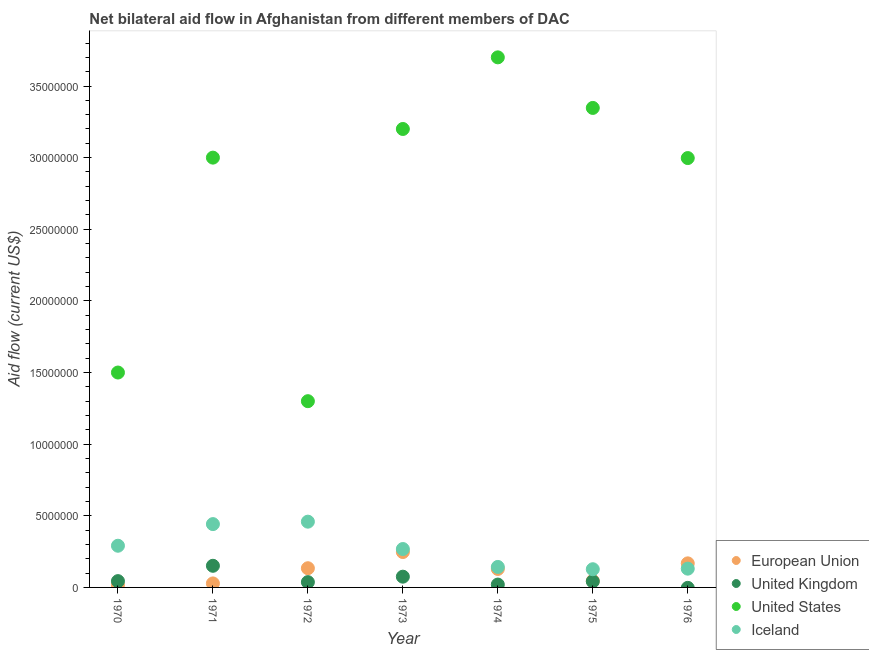What is the amount of aid given by iceland in 1971?
Offer a very short reply. 4.42e+06. Across all years, what is the maximum amount of aid given by iceland?
Give a very brief answer. 4.59e+06. Across all years, what is the minimum amount of aid given by eu?
Make the answer very short. 1.60e+05. In which year was the amount of aid given by iceland maximum?
Keep it short and to the point. 1972. What is the total amount of aid given by eu in the graph?
Offer a very short reply. 7.68e+06. What is the difference between the amount of aid given by iceland in 1970 and that in 1973?
Your answer should be very brief. 2.30e+05. What is the difference between the amount of aid given by eu in 1975 and the amount of aid given by us in 1970?
Your answer should be compact. -1.45e+07. What is the average amount of aid given by eu per year?
Offer a terse response. 1.10e+06. In the year 1974, what is the difference between the amount of aid given by iceland and amount of aid given by us?
Make the answer very short. -3.56e+07. What is the ratio of the amount of aid given by iceland in 1970 to that in 1974?
Ensure brevity in your answer.  2.03. Is the difference between the amount of aid given by us in 1974 and 1976 greater than the difference between the amount of aid given by iceland in 1974 and 1976?
Keep it short and to the point. Yes. What is the difference between the highest and the second highest amount of aid given by us?
Keep it short and to the point. 3.53e+06. What is the difference between the highest and the lowest amount of aid given by uk?
Provide a succinct answer. 1.51e+06. In how many years, is the amount of aid given by us greater than the average amount of aid given by us taken over all years?
Your answer should be very brief. 5. Is it the case that in every year, the sum of the amount of aid given by eu and amount of aid given by iceland is greater than the sum of amount of aid given by us and amount of aid given by uk?
Your response must be concise. No. Does the amount of aid given by iceland monotonically increase over the years?
Your answer should be very brief. No. Is the amount of aid given by iceland strictly greater than the amount of aid given by us over the years?
Your answer should be very brief. No. Is the amount of aid given by us strictly less than the amount of aid given by uk over the years?
Your answer should be very brief. No. Are the values on the major ticks of Y-axis written in scientific E-notation?
Offer a terse response. No. How many legend labels are there?
Offer a terse response. 4. What is the title of the graph?
Ensure brevity in your answer.  Net bilateral aid flow in Afghanistan from different members of DAC. Does "Second 20% of population" appear as one of the legend labels in the graph?
Your response must be concise. No. What is the Aid flow (current US$) of European Union in 1970?
Ensure brevity in your answer.  1.60e+05. What is the Aid flow (current US$) in United States in 1970?
Your answer should be very brief. 1.50e+07. What is the Aid flow (current US$) in Iceland in 1970?
Your answer should be very brief. 2.91e+06. What is the Aid flow (current US$) in European Union in 1971?
Your answer should be compact. 2.80e+05. What is the Aid flow (current US$) in United Kingdom in 1971?
Offer a terse response. 1.51e+06. What is the Aid flow (current US$) in United States in 1971?
Your answer should be compact. 3.00e+07. What is the Aid flow (current US$) of Iceland in 1971?
Provide a short and direct response. 4.42e+06. What is the Aid flow (current US$) in European Union in 1972?
Offer a terse response. 1.34e+06. What is the Aid flow (current US$) in United States in 1972?
Ensure brevity in your answer.  1.30e+07. What is the Aid flow (current US$) of Iceland in 1972?
Ensure brevity in your answer.  4.59e+06. What is the Aid flow (current US$) in European Union in 1973?
Give a very brief answer. 2.47e+06. What is the Aid flow (current US$) of United Kingdom in 1973?
Offer a very short reply. 7.50e+05. What is the Aid flow (current US$) of United States in 1973?
Your answer should be very brief. 3.20e+07. What is the Aid flow (current US$) in Iceland in 1973?
Your answer should be very brief. 2.68e+06. What is the Aid flow (current US$) of European Union in 1974?
Provide a succinct answer. 1.29e+06. What is the Aid flow (current US$) of United States in 1974?
Your response must be concise. 3.70e+07. What is the Aid flow (current US$) of Iceland in 1974?
Provide a succinct answer. 1.43e+06. What is the Aid flow (current US$) of United Kingdom in 1975?
Ensure brevity in your answer.  4.20e+05. What is the Aid flow (current US$) of United States in 1975?
Provide a short and direct response. 3.35e+07. What is the Aid flow (current US$) of Iceland in 1975?
Provide a succinct answer. 1.27e+06. What is the Aid flow (current US$) in European Union in 1976?
Make the answer very short. 1.68e+06. What is the Aid flow (current US$) of United Kingdom in 1976?
Provide a short and direct response. 0. What is the Aid flow (current US$) in United States in 1976?
Your answer should be very brief. 3.00e+07. What is the Aid flow (current US$) in Iceland in 1976?
Offer a very short reply. 1.31e+06. Across all years, what is the maximum Aid flow (current US$) in European Union?
Your answer should be very brief. 2.47e+06. Across all years, what is the maximum Aid flow (current US$) of United Kingdom?
Give a very brief answer. 1.51e+06. Across all years, what is the maximum Aid flow (current US$) of United States?
Give a very brief answer. 3.70e+07. Across all years, what is the maximum Aid flow (current US$) of Iceland?
Give a very brief answer. 4.59e+06. Across all years, what is the minimum Aid flow (current US$) in United Kingdom?
Offer a very short reply. 0. Across all years, what is the minimum Aid flow (current US$) of United States?
Keep it short and to the point. 1.30e+07. Across all years, what is the minimum Aid flow (current US$) of Iceland?
Give a very brief answer. 1.27e+06. What is the total Aid flow (current US$) of European Union in the graph?
Ensure brevity in your answer.  7.68e+06. What is the total Aid flow (current US$) in United Kingdom in the graph?
Make the answer very short. 3.69e+06. What is the total Aid flow (current US$) of United States in the graph?
Give a very brief answer. 1.90e+08. What is the total Aid flow (current US$) in Iceland in the graph?
Ensure brevity in your answer.  1.86e+07. What is the difference between the Aid flow (current US$) of United Kingdom in 1970 and that in 1971?
Provide a short and direct response. -1.07e+06. What is the difference between the Aid flow (current US$) in United States in 1970 and that in 1971?
Provide a succinct answer. -1.50e+07. What is the difference between the Aid flow (current US$) in Iceland in 1970 and that in 1971?
Keep it short and to the point. -1.51e+06. What is the difference between the Aid flow (current US$) in European Union in 1970 and that in 1972?
Your answer should be very brief. -1.18e+06. What is the difference between the Aid flow (current US$) of Iceland in 1970 and that in 1972?
Provide a short and direct response. -1.68e+06. What is the difference between the Aid flow (current US$) in European Union in 1970 and that in 1973?
Your answer should be compact. -2.31e+06. What is the difference between the Aid flow (current US$) of United Kingdom in 1970 and that in 1973?
Keep it short and to the point. -3.10e+05. What is the difference between the Aid flow (current US$) of United States in 1970 and that in 1973?
Keep it short and to the point. -1.70e+07. What is the difference between the Aid flow (current US$) in European Union in 1970 and that in 1974?
Give a very brief answer. -1.13e+06. What is the difference between the Aid flow (current US$) in United States in 1970 and that in 1974?
Give a very brief answer. -2.20e+07. What is the difference between the Aid flow (current US$) in Iceland in 1970 and that in 1974?
Your answer should be compact. 1.48e+06. What is the difference between the Aid flow (current US$) of European Union in 1970 and that in 1975?
Make the answer very short. -3.00e+05. What is the difference between the Aid flow (current US$) in United States in 1970 and that in 1975?
Provide a succinct answer. -1.85e+07. What is the difference between the Aid flow (current US$) in Iceland in 1970 and that in 1975?
Make the answer very short. 1.64e+06. What is the difference between the Aid flow (current US$) of European Union in 1970 and that in 1976?
Provide a short and direct response. -1.52e+06. What is the difference between the Aid flow (current US$) of United States in 1970 and that in 1976?
Keep it short and to the point. -1.50e+07. What is the difference between the Aid flow (current US$) in Iceland in 1970 and that in 1976?
Your answer should be very brief. 1.60e+06. What is the difference between the Aid flow (current US$) in European Union in 1971 and that in 1972?
Make the answer very short. -1.06e+06. What is the difference between the Aid flow (current US$) of United Kingdom in 1971 and that in 1972?
Your answer should be compact. 1.14e+06. What is the difference between the Aid flow (current US$) of United States in 1971 and that in 1972?
Make the answer very short. 1.70e+07. What is the difference between the Aid flow (current US$) of European Union in 1971 and that in 1973?
Provide a succinct answer. -2.19e+06. What is the difference between the Aid flow (current US$) of United Kingdom in 1971 and that in 1973?
Make the answer very short. 7.60e+05. What is the difference between the Aid flow (current US$) of United States in 1971 and that in 1973?
Provide a short and direct response. -2.00e+06. What is the difference between the Aid flow (current US$) in Iceland in 1971 and that in 1973?
Your answer should be compact. 1.74e+06. What is the difference between the Aid flow (current US$) of European Union in 1971 and that in 1974?
Provide a short and direct response. -1.01e+06. What is the difference between the Aid flow (current US$) of United Kingdom in 1971 and that in 1974?
Offer a very short reply. 1.31e+06. What is the difference between the Aid flow (current US$) of United States in 1971 and that in 1974?
Your answer should be compact. -7.00e+06. What is the difference between the Aid flow (current US$) in Iceland in 1971 and that in 1974?
Ensure brevity in your answer.  2.99e+06. What is the difference between the Aid flow (current US$) in United Kingdom in 1971 and that in 1975?
Provide a short and direct response. 1.09e+06. What is the difference between the Aid flow (current US$) of United States in 1971 and that in 1975?
Offer a terse response. -3.47e+06. What is the difference between the Aid flow (current US$) of Iceland in 1971 and that in 1975?
Offer a terse response. 3.15e+06. What is the difference between the Aid flow (current US$) in European Union in 1971 and that in 1976?
Provide a succinct answer. -1.40e+06. What is the difference between the Aid flow (current US$) of Iceland in 1971 and that in 1976?
Ensure brevity in your answer.  3.11e+06. What is the difference between the Aid flow (current US$) of European Union in 1972 and that in 1973?
Offer a very short reply. -1.13e+06. What is the difference between the Aid flow (current US$) in United Kingdom in 1972 and that in 1973?
Your response must be concise. -3.80e+05. What is the difference between the Aid flow (current US$) of United States in 1972 and that in 1973?
Offer a terse response. -1.90e+07. What is the difference between the Aid flow (current US$) of Iceland in 1972 and that in 1973?
Your answer should be compact. 1.91e+06. What is the difference between the Aid flow (current US$) in European Union in 1972 and that in 1974?
Your answer should be very brief. 5.00e+04. What is the difference between the Aid flow (current US$) of United States in 1972 and that in 1974?
Provide a succinct answer. -2.40e+07. What is the difference between the Aid flow (current US$) in Iceland in 1972 and that in 1974?
Make the answer very short. 3.16e+06. What is the difference between the Aid flow (current US$) of European Union in 1972 and that in 1975?
Keep it short and to the point. 8.80e+05. What is the difference between the Aid flow (current US$) of United Kingdom in 1972 and that in 1975?
Make the answer very short. -5.00e+04. What is the difference between the Aid flow (current US$) of United States in 1972 and that in 1975?
Your answer should be compact. -2.05e+07. What is the difference between the Aid flow (current US$) of Iceland in 1972 and that in 1975?
Make the answer very short. 3.32e+06. What is the difference between the Aid flow (current US$) of United States in 1972 and that in 1976?
Ensure brevity in your answer.  -1.70e+07. What is the difference between the Aid flow (current US$) in Iceland in 1972 and that in 1976?
Make the answer very short. 3.28e+06. What is the difference between the Aid flow (current US$) of European Union in 1973 and that in 1974?
Give a very brief answer. 1.18e+06. What is the difference between the Aid flow (current US$) of United States in 1973 and that in 1974?
Provide a succinct answer. -5.00e+06. What is the difference between the Aid flow (current US$) of Iceland in 1973 and that in 1974?
Make the answer very short. 1.25e+06. What is the difference between the Aid flow (current US$) in European Union in 1973 and that in 1975?
Your answer should be very brief. 2.01e+06. What is the difference between the Aid flow (current US$) of United Kingdom in 1973 and that in 1975?
Offer a terse response. 3.30e+05. What is the difference between the Aid flow (current US$) of United States in 1973 and that in 1975?
Your answer should be compact. -1.47e+06. What is the difference between the Aid flow (current US$) of Iceland in 1973 and that in 1975?
Offer a very short reply. 1.41e+06. What is the difference between the Aid flow (current US$) in European Union in 1973 and that in 1976?
Offer a terse response. 7.90e+05. What is the difference between the Aid flow (current US$) of United States in 1973 and that in 1976?
Provide a succinct answer. 2.03e+06. What is the difference between the Aid flow (current US$) in Iceland in 1973 and that in 1976?
Provide a short and direct response. 1.37e+06. What is the difference between the Aid flow (current US$) of European Union in 1974 and that in 1975?
Ensure brevity in your answer.  8.30e+05. What is the difference between the Aid flow (current US$) in United Kingdom in 1974 and that in 1975?
Provide a short and direct response. -2.20e+05. What is the difference between the Aid flow (current US$) of United States in 1974 and that in 1975?
Provide a short and direct response. 3.53e+06. What is the difference between the Aid flow (current US$) in Iceland in 1974 and that in 1975?
Offer a terse response. 1.60e+05. What is the difference between the Aid flow (current US$) of European Union in 1974 and that in 1976?
Offer a terse response. -3.90e+05. What is the difference between the Aid flow (current US$) of United States in 1974 and that in 1976?
Provide a short and direct response. 7.03e+06. What is the difference between the Aid flow (current US$) of European Union in 1975 and that in 1976?
Keep it short and to the point. -1.22e+06. What is the difference between the Aid flow (current US$) in United States in 1975 and that in 1976?
Ensure brevity in your answer.  3.50e+06. What is the difference between the Aid flow (current US$) in European Union in 1970 and the Aid flow (current US$) in United Kingdom in 1971?
Your answer should be compact. -1.35e+06. What is the difference between the Aid flow (current US$) in European Union in 1970 and the Aid flow (current US$) in United States in 1971?
Your answer should be compact. -2.98e+07. What is the difference between the Aid flow (current US$) of European Union in 1970 and the Aid flow (current US$) of Iceland in 1971?
Ensure brevity in your answer.  -4.26e+06. What is the difference between the Aid flow (current US$) of United Kingdom in 1970 and the Aid flow (current US$) of United States in 1971?
Give a very brief answer. -2.96e+07. What is the difference between the Aid flow (current US$) of United Kingdom in 1970 and the Aid flow (current US$) of Iceland in 1971?
Your answer should be compact. -3.98e+06. What is the difference between the Aid flow (current US$) of United States in 1970 and the Aid flow (current US$) of Iceland in 1971?
Your response must be concise. 1.06e+07. What is the difference between the Aid flow (current US$) in European Union in 1970 and the Aid flow (current US$) in United States in 1972?
Your answer should be compact. -1.28e+07. What is the difference between the Aid flow (current US$) of European Union in 1970 and the Aid flow (current US$) of Iceland in 1972?
Keep it short and to the point. -4.43e+06. What is the difference between the Aid flow (current US$) in United Kingdom in 1970 and the Aid flow (current US$) in United States in 1972?
Give a very brief answer. -1.26e+07. What is the difference between the Aid flow (current US$) of United Kingdom in 1970 and the Aid flow (current US$) of Iceland in 1972?
Keep it short and to the point. -4.15e+06. What is the difference between the Aid flow (current US$) of United States in 1970 and the Aid flow (current US$) of Iceland in 1972?
Make the answer very short. 1.04e+07. What is the difference between the Aid flow (current US$) of European Union in 1970 and the Aid flow (current US$) of United Kingdom in 1973?
Ensure brevity in your answer.  -5.90e+05. What is the difference between the Aid flow (current US$) of European Union in 1970 and the Aid flow (current US$) of United States in 1973?
Ensure brevity in your answer.  -3.18e+07. What is the difference between the Aid flow (current US$) in European Union in 1970 and the Aid flow (current US$) in Iceland in 1973?
Give a very brief answer. -2.52e+06. What is the difference between the Aid flow (current US$) in United Kingdom in 1970 and the Aid flow (current US$) in United States in 1973?
Your answer should be compact. -3.16e+07. What is the difference between the Aid flow (current US$) in United Kingdom in 1970 and the Aid flow (current US$) in Iceland in 1973?
Keep it short and to the point. -2.24e+06. What is the difference between the Aid flow (current US$) of United States in 1970 and the Aid flow (current US$) of Iceland in 1973?
Keep it short and to the point. 1.23e+07. What is the difference between the Aid flow (current US$) in European Union in 1970 and the Aid flow (current US$) in United Kingdom in 1974?
Your answer should be very brief. -4.00e+04. What is the difference between the Aid flow (current US$) in European Union in 1970 and the Aid flow (current US$) in United States in 1974?
Ensure brevity in your answer.  -3.68e+07. What is the difference between the Aid flow (current US$) in European Union in 1970 and the Aid flow (current US$) in Iceland in 1974?
Give a very brief answer. -1.27e+06. What is the difference between the Aid flow (current US$) of United Kingdom in 1970 and the Aid flow (current US$) of United States in 1974?
Give a very brief answer. -3.66e+07. What is the difference between the Aid flow (current US$) of United Kingdom in 1970 and the Aid flow (current US$) of Iceland in 1974?
Provide a succinct answer. -9.90e+05. What is the difference between the Aid flow (current US$) in United States in 1970 and the Aid flow (current US$) in Iceland in 1974?
Provide a succinct answer. 1.36e+07. What is the difference between the Aid flow (current US$) in European Union in 1970 and the Aid flow (current US$) in United Kingdom in 1975?
Give a very brief answer. -2.60e+05. What is the difference between the Aid flow (current US$) of European Union in 1970 and the Aid flow (current US$) of United States in 1975?
Your answer should be very brief. -3.33e+07. What is the difference between the Aid flow (current US$) of European Union in 1970 and the Aid flow (current US$) of Iceland in 1975?
Your response must be concise. -1.11e+06. What is the difference between the Aid flow (current US$) of United Kingdom in 1970 and the Aid flow (current US$) of United States in 1975?
Your answer should be very brief. -3.30e+07. What is the difference between the Aid flow (current US$) of United Kingdom in 1970 and the Aid flow (current US$) of Iceland in 1975?
Ensure brevity in your answer.  -8.30e+05. What is the difference between the Aid flow (current US$) of United States in 1970 and the Aid flow (current US$) of Iceland in 1975?
Ensure brevity in your answer.  1.37e+07. What is the difference between the Aid flow (current US$) in European Union in 1970 and the Aid flow (current US$) in United States in 1976?
Your answer should be very brief. -2.98e+07. What is the difference between the Aid flow (current US$) of European Union in 1970 and the Aid flow (current US$) of Iceland in 1976?
Make the answer very short. -1.15e+06. What is the difference between the Aid flow (current US$) of United Kingdom in 1970 and the Aid flow (current US$) of United States in 1976?
Offer a terse response. -2.95e+07. What is the difference between the Aid flow (current US$) of United Kingdom in 1970 and the Aid flow (current US$) of Iceland in 1976?
Your answer should be very brief. -8.70e+05. What is the difference between the Aid flow (current US$) of United States in 1970 and the Aid flow (current US$) of Iceland in 1976?
Keep it short and to the point. 1.37e+07. What is the difference between the Aid flow (current US$) in European Union in 1971 and the Aid flow (current US$) in United States in 1972?
Your answer should be compact. -1.27e+07. What is the difference between the Aid flow (current US$) of European Union in 1971 and the Aid flow (current US$) of Iceland in 1972?
Give a very brief answer. -4.31e+06. What is the difference between the Aid flow (current US$) in United Kingdom in 1971 and the Aid flow (current US$) in United States in 1972?
Provide a succinct answer. -1.15e+07. What is the difference between the Aid flow (current US$) in United Kingdom in 1971 and the Aid flow (current US$) in Iceland in 1972?
Offer a terse response. -3.08e+06. What is the difference between the Aid flow (current US$) of United States in 1971 and the Aid flow (current US$) of Iceland in 1972?
Keep it short and to the point. 2.54e+07. What is the difference between the Aid flow (current US$) in European Union in 1971 and the Aid flow (current US$) in United Kingdom in 1973?
Your answer should be very brief. -4.70e+05. What is the difference between the Aid flow (current US$) of European Union in 1971 and the Aid flow (current US$) of United States in 1973?
Make the answer very short. -3.17e+07. What is the difference between the Aid flow (current US$) of European Union in 1971 and the Aid flow (current US$) of Iceland in 1973?
Offer a terse response. -2.40e+06. What is the difference between the Aid flow (current US$) of United Kingdom in 1971 and the Aid flow (current US$) of United States in 1973?
Your answer should be very brief. -3.05e+07. What is the difference between the Aid flow (current US$) of United Kingdom in 1971 and the Aid flow (current US$) of Iceland in 1973?
Make the answer very short. -1.17e+06. What is the difference between the Aid flow (current US$) of United States in 1971 and the Aid flow (current US$) of Iceland in 1973?
Ensure brevity in your answer.  2.73e+07. What is the difference between the Aid flow (current US$) in European Union in 1971 and the Aid flow (current US$) in United Kingdom in 1974?
Provide a short and direct response. 8.00e+04. What is the difference between the Aid flow (current US$) of European Union in 1971 and the Aid flow (current US$) of United States in 1974?
Provide a succinct answer. -3.67e+07. What is the difference between the Aid flow (current US$) of European Union in 1971 and the Aid flow (current US$) of Iceland in 1974?
Give a very brief answer. -1.15e+06. What is the difference between the Aid flow (current US$) in United Kingdom in 1971 and the Aid flow (current US$) in United States in 1974?
Your response must be concise. -3.55e+07. What is the difference between the Aid flow (current US$) of United Kingdom in 1971 and the Aid flow (current US$) of Iceland in 1974?
Your answer should be compact. 8.00e+04. What is the difference between the Aid flow (current US$) in United States in 1971 and the Aid flow (current US$) in Iceland in 1974?
Provide a succinct answer. 2.86e+07. What is the difference between the Aid flow (current US$) in European Union in 1971 and the Aid flow (current US$) in United Kingdom in 1975?
Make the answer very short. -1.40e+05. What is the difference between the Aid flow (current US$) in European Union in 1971 and the Aid flow (current US$) in United States in 1975?
Ensure brevity in your answer.  -3.32e+07. What is the difference between the Aid flow (current US$) in European Union in 1971 and the Aid flow (current US$) in Iceland in 1975?
Offer a very short reply. -9.90e+05. What is the difference between the Aid flow (current US$) of United Kingdom in 1971 and the Aid flow (current US$) of United States in 1975?
Make the answer very short. -3.20e+07. What is the difference between the Aid flow (current US$) in United States in 1971 and the Aid flow (current US$) in Iceland in 1975?
Make the answer very short. 2.87e+07. What is the difference between the Aid flow (current US$) of European Union in 1971 and the Aid flow (current US$) of United States in 1976?
Provide a short and direct response. -2.97e+07. What is the difference between the Aid flow (current US$) in European Union in 1971 and the Aid flow (current US$) in Iceland in 1976?
Provide a short and direct response. -1.03e+06. What is the difference between the Aid flow (current US$) of United Kingdom in 1971 and the Aid flow (current US$) of United States in 1976?
Offer a very short reply. -2.85e+07. What is the difference between the Aid flow (current US$) of United Kingdom in 1971 and the Aid flow (current US$) of Iceland in 1976?
Give a very brief answer. 2.00e+05. What is the difference between the Aid flow (current US$) in United States in 1971 and the Aid flow (current US$) in Iceland in 1976?
Your answer should be compact. 2.87e+07. What is the difference between the Aid flow (current US$) of European Union in 1972 and the Aid flow (current US$) of United Kingdom in 1973?
Offer a very short reply. 5.90e+05. What is the difference between the Aid flow (current US$) in European Union in 1972 and the Aid flow (current US$) in United States in 1973?
Your answer should be compact. -3.07e+07. What is the difference between the Aid flow (current US$) in European Union in 1972 and the Aid flow (current US$) in Iceland in 1973?
Your response must be concise. -1.34e+06. What is the difference between the Aid flow (current US$) in United Kingdom in 1972 and the Aid flow (current US$) in United States in 1973?
Ensure brevity in your answer.  -3.16e+07. What is the difference between the Aid flow (current US$) of United Kingdom in 1972 and the Aid flow (current US$) of Iceland in 1973?
Give a very brief answer. -2.31e+06. What is the difference between the Aid flow (current US$) in United States in 1972 and the Aid flow (current US$) in Iceland in 1973?
Your response must be concise. 1.03e+07. What is the difference between the Aid flow (current US$) of European Union in 1972 and the Aid flow (current US$) of United Kingdom in 1974?
Your answer should be very brief. 1.14e+06. What is the difference between the Aid flow (current US$) of European Union in 1972 and the Aid flow (current US$) of United States in 1974?
Keep it short and to the point. -3.57e+07. What is the difference between the Aid flow (current US$) of European Union in 1972 and the Aid flow (current US$) of Iceland in 1974?
Your response must be concise. -9.00e+04. What is the difference between the Aid flow (current US$) in United Kingdom in 1972 and the Aid flow (current US$) in United States in 1974?
Give a very brief answer. -3.66e+07. What is the difference between the Aid flow (current US$) of United Kingdom in 1972 and the Aid flow (current US$) of Iceland in 1974?
Keep it short and to the point. -1.06e+06. What is the difference between the Aid flow (current US$) in United States in 1972 and the Aid flow (current US$) in Iceland in 1974?
Provide a succinct answer. 1.16e+07. What is the difference between the Aid flow (current US$) of European Union in 1972 and the Aid flow (current US$) of United Kingdom in 1975?
Give a very brief answer. 9.20e+05. What is the difference between the Aid flow (current US$) in European Union in 1972 and the Aid flow (current US$) in United States in 1975?
Keep it short and to the point. -3.21e+07. What is the difference between the Aid flow (current US$) in United Kingdom in 1972 and the Aid flow (current US$) in United States in 1975?
Offer a terse response. -3.31e+07. What is the difference between the Aid flow (current US$) in United Kingdom in 1972 and the Aid flow (current US$) in Iceland in 1975?
Offer a very short reply. -9.00e+05. What is the difference between the Aid flow (current US$) of United States in 1972 and the Aid flow (current US$) of Iceland in 1975?
Provide a succinct answer. 1.17e+07. What is the difference between the Aid flow (current US$) of European Union in 1972 and the Aid flow (current US$) of United States in 1976?
Provide a short and direct response. -2.86e+07. What is the difference between the Aid flow (current US$) of United Kingdom in 1972 and the Aid flow (current US$) of United States in 1976?
Your answer should be compact. -2.96e+07. What is the difference between the Aid flow (current US$) in United Kingdom in 1972 and the Aid flow (current US$) in Iceland in 1976?
Give a very brief answer. -9.40e+05. What is the difference between the Aid flow (current US$) in United States in 1972 and the Aid flow (current US$) in Iceland in 1976?
Provide a short and direct response. 1.17e+07. What is the difference between the Aid flow (current US$) in European Union in 1973 and the Aid flow (current US$) in United Kingdom in 1974?
Ensure brevity in your answer.  2.27e+06. What is the difference between the Aid flow (current US$) of European Union in 1973 and the Aid flow (current US$) of United States in 1974?
Keep it short and to the point. -3.45e+07. What is the difference between the Aid flow (current US$) of European Union in 1973 and the Aid flow (current US$) of Iceland in 1974?
Your response must be concise. 1.04e+06. What is the difference between the Aid flow (current US$) of United Kingdom in 1973 and the Aid flow (current US$) of United States in 1974?
Offer a terse response. -3.62e+07. What is the difference between the Aid flow (current US$) of United Kingdom in 1973 and the Aid flow (current US$) of Iceland in 1974?
Provide a succinct answer. -6.80e+05. What is the difference between the Aid flow (current US$) of United States in 1973 and the Aid flow (current US$) of Iceland in 1974?
Your answer should be compact. 3.06e+07. What is the difference between the Aid flow (current US$) in European Union in 1973 and the Aid flow (current US$) in United Kingdom in 1975?
Your answer should be compact. 2.05e+06. What is the difference between the Aid flow (current US$) of European Union in 1973 and the Aid flow (current US$) of United States in 1975?
Keep it short and to the point. -3.10e+07. What is the difference between the Aid flow (current US$) in European Union in 1973 and the Aid flow (current US$) in Iceland in 1975?
Ensure brevity in your answer.  1.20e+06. What is the difference between the Aid flow (current US$) of United Kingdom in 1973 and the Aid flow (current US$) of United States in 1975?
Your response must be concise. -3.27e+07. What is the difference between the Aid flow (current US$) in United Kingdom in 1973 and the Aid flow (current US$) in Iceland in 1975?
Give a very brief answer. -5.20e+05. What is the difference between the Aid flow (current US$) of United States in 1973 and the Aid flow (current US$) of Iceland in 1975?
Make the answer very short. 3.07e+07. What is the difference between the Aid flow (current US$) in European Union in 1973 and the Aid flow (current US$) in United States in 1976?
Your response must be concise. -2.75e+07. What is the difference between the Aid flow (current US$) of European Union in 1973 and the Aid flow (current US$) of Iceland in 1976?
Give a very brief answer. 1.16e+06. What is the difference between the Aid flow (current US$) in United Kingdom in 1973 and the Aid flow (current US$) in United States in 1976?
Provide a short and direct response. -2.92e+07. What is the difference between the Aid flow (current US$) in United Kingdom in 1973 and the Aid flow (current US$) in Iceland in 1976?
Your answer should be compact. -5.60e+05. What is the difference between the Aid flow (current US$) in United States in 1973 and the Aid flow (current US$) in Iceland in 1976?
Give a very brief answer. 3.07e+07. What is the difference between the Aid flow (current US$) in European Union in 1974 and the Aid flow (current US$) in United Kingdom in 1975?
Give a very brief answer. 8.70e+05. What is the difference between the Aid flow (current US$) in European Union in 1974 and the Aid flow (current US$) in United States in 1975?
Your answer should be compact. -3.22e+07. What is the difference between the Aid flow (current US$) of European Union in 1974 and the Aid flow (current US$) of Iceland in 1975?
Provide a succinct answer. 2.00e+04. What is the difference between the Aid flow (current US$) in United Kingdom in 1974 and the Aid flow (current US$) in United States in 1975?
Your answer should be compact. -3.33e+07. What is the difference between the Aid flow (current US$) in United Kingdom in 1974 and the Aid flow (current US$) in Iceland in 1975?
Offer a very short reply. -1.07e+06. What is the difference between the Aid flow (current US$) in United States in 1974 and the Aid flow (current US$) in Iceland in 1975?
Make the answer very short. 3.57e+07. What is the difference between the Aid flow (current US$) in European Union in 1974 and the Aid flow (current US$) in United States in 1976?
Offer a very short reply. -2.87e+07. What is the difference between the Aid flow (current US$) of United Kingdom in 1974 and the Aid flow (current US$) of United States in 1976?
Make the answer very short. -2.98e+07. What is the difference between the Aid flow (current US$) of United Kingdom in 1974 and the Aid flow (current US$) of Iceland in 1976?
Make the answer very short. -1.11e+06. What is the difference between the Aid flow (current US$) of United States in 1974 and the Aid flow (current US$) of Iceland in 1976?
Offer a very short reply. 3.57e+07. What is the difference between the Aid flow (current US$) in European Union in 1975 and the Aid flow (current US$) in United States in 1976?
Provide a short and direct response. -2.95e+07. What is the difference between the Aid flow (current US$) in European Union in 1975 and the Aid flow (current US$) in Iceland in 1976?
Provide a short and direct response. -8.50e+05. What is the difference between the Aid flow (current US$) of United Kingdom in 1975 and the Aid flow (current US$) of United States in 1976?
Provide a succinct answer. -2.96e+07. What is the difference between the Aid flow (current US$) in United Kingdom in 1975 and the Aid flow (current US$) in Iceland in 1976?
Your response must be concise. -8.90e+05. What is the difference between the Aid flow (current US$) of United States in 1975 and the Aid flow (current US$) of Iceland in 1976?
Keep it short and to the point. 3.22e+07. What is the average Aid flow (current US$) in European Union per year?
Your answer should be compact. 1.10e+06. What is the average Aid flow (current US$) in United Kingdom per year?
Your answer should be very brief. 5.27e+05. What is the average Aid flow (current US$) of United States per year?
Your answer should be very brief. 2.72e+07. What is the average Aid flow (current US$) of Iceland per year?
Your answer should be very brief. 2.66e+06. In the year 1970, what is the difference between the Aid flow (current US$) of European Union and Aid flow (current US$) of United Kingdom?
Your answer should be compact. -2.80e+05. In the year 1970, what is the difference between the Aid flow (current US$) of European Union and Aid flow (current US$) of United States?
Your answer should be very brief. -1.48e+07. In the year 1970, what is the difference between the Aid flow (current US$) of European Union and Aid flow (current US$) of Iceland?
Your answer should be compact. -2.75e+06. In the year 1970, what is the difference between the Aid flow (current US$) of United Kingdom and Aid flow (current US$) of United States?
Provide a succinct answer. -1.46e+07. In the year 1970, what is the difference between the Aid flow (current US$) of United Kingdom and Aid flow (current US$) of Iceland?
Offer a very short reply. -2.47e+06. In the year 1970, what is the difference between the Aid flow (current US$) of United States and Aid flow (current US$) of Iceland?
Give a very brief answer. 1.21e+07. In the year 1971, what is the difference between the Aid flow (current US$) in European Union and Aid flow (current US$) in United Kingdom?
Keep it short and to the point. -1.23e+06. In the year 1971, what is the difference between the Aid flow (current US$) in European Union and Aid flow (current US$) in United States?
Your response must be concise. -2.97e+07. In the year 1971, what is the difference between the Aid flow (current US$) of European Union and Aid flow (current US$) of Iceland?
Keep it short and to the point. -4.14e+06. In the year 1971, what is the difference between the Aid flow (current US$) of United Kingdom and Aid flow (current US$) of United States?
Your answer should be compact. -2.85e+07. In the year 1971, what is the difference between the Aid flow (current US$) in United Kingdom and Aid flow (current US$) in Iceland?
Ensure brevity in your answer.  -2.91e+06. In the year 1971, what is the difference between the Aid flow (current US$) of United States and Aid flow (current US$) of Iceland?
Offer a very short reply. 2.56e+07. In the year 1972, what is the difference between the Aid flow (current US$) in European Union and Aid flow (current US$) in United Kingdom?
Offer a terse response. 9.70e+05. In the year 1972, what is the difference between the Aid flow (current US$) of European Union and Aid flow (current US$) of United States?
Offer a terse response. -1.17e+07. In the year 1972, what is the difference between the Aid flow (current US$) of European Union and Aid flow (current US$) of Iceland?
Offer a terse response. -3.25e+06. In the year 1972, what is the difference between the Aid flow (current US$) in United Kingdom and Aid flow (current US$) in United States?
Your answer should be very brief. -1.26e+07. In the year 1972, what is the difference between the Aid flow (current US$) in United Kingdom and Aid flow (current US$) in Iceland?
Give a very brief answer. -4.22e+06. In the year 1972, what is the difference between the Aid flow (current US$) of United States and Aid flow (current US$) of Iceland?
Offer a very short reply. 8.41e+06. In the year 1973, what is the difference between the Aid flow (current US$) of European Union and Aid flow (current US$) of United Kingdom?
Ensure brevity in your answer.  1.72e+06. In the year 1973, what is the difference between the Aid flow (current US$) of European Union and Aid flow (current US$) of United States?
Give a very brief answer. -2.95e+07. In the year 1973, what is the difference between the Aid flow (current US$) of United Kingdom and Aid flow (current US$) of United States?
Give a very brief answer. -3.12e+07. In the year 1973, what is the difference between the Aid flow (current US$) of United Kingdom and Aid flow (current US$) of Iceland?
Offer a terse response. -1.93e+06. In the year 1973, what is the difference between the Aid flow (current US$) in United States and Aid flow (current US$) in Iceland?
Offer a very short reply. 2.93e+07. In the year 1974, what is the difference between the Aid flow (current US$) in European Union and Aid flow (current US$) in United Kingdom?
Provide a short and direct response. 1.09e+06. In the year 1974, what is the difference between the Aid flow (current US$) of European Union and Aid flow (current US$) of United States?
Keep it short and to the point. -3.57e+07. In the year 1974, what is the difference between the Aid flow (current US$) in European Union and Aid flow (current US$) in Iceland?
Your answer should be very brief. -1.40e+05. In the year 1974, what is the difference between the Aid flow (current US$) in United Kingdom and Aid flow (current US$) in United States?
Ensure brevity in your answer.  -3.68e+07. In the year 1974, what is the difference between the Aid flow (current US$) in United Kingdom and Aid flow (current US$) in Iceland?
Keep it short and to the point. -1.23e+06. In the year 1974, what is the difference between the Aid flow (current US$) of United States and Aid flow (current US$) of Iceland?
Provide a short and direct response. 3.56e+07. In the year 1975, what is the difference between the Aid flow (current US$) of European Union and Aid flow (current US$) of United States?
Provide a short and direct response. -3.30e+07. In the year 1975, what is the difference between the Aid flow (current US$) of European Union and Aid flow (current US$) of Iceland?
Keep it short and to the point. -8.10e+05. In the year 1975, what is the difference between the Aid flow (current US$) in United Kingdom and Aid flow (current US$) in United States?
Ensure brevity in your answer.  -3.30e+07. In the year 1975, what is the difference between the Aid flow (current US$) in United Kingdom and Aid flow (current US$) in Iceland?
Your answer should be compact. -8.50e+05. In the year 1975, what is the difference between the Aid flow (current US$) of United States and Aid flow (current US$) of Iceland?
Offer a terse response. 3.22e+07. In the year 1976, what is the difference between the Aid flow (current US$) of European Union and Aid flow (current US$) of United States?
Ensure brevity in your answer.  -2.83e+07. In the year 1976, what is the difference between the Aid flow (current US$) in United States and Aid flow (current US$) in Iceland?
Ensure brevity in your answer.  2.87e+07. What is the ratio of the Aid flow (current US$) of United Kingdom in 1970 to that in 1971?
Offer a terse response. 0.29. What is the ratio of the Aid flow (current US$) of United States in 1970 to that in 1971?
Your answer should be very brief. 0.5. What is the ratio of the Aid flow (current US$) in Iceland in 1970 to that in 1971?
Keep it short and to the point. 0.66. What is the ratio of the Aid flow (current US$) of European Union in 1970 to that in 1972?
Give a very brief answer. 0.12. What is the ratio of the Aid flow (current US$) in United Kingdom in 1970 to that in 1972?
Offer a terse response. 1.19. What is the ratio of the Aid flow (current US$) in United States in 1970 to that in 1972?
Provide a succinct answer. 1.15. What is the ratio of the Aid flow (current US$) of Iceland in 1970 to that in 1972?
Keep it short and to the point. 0.63. What is the ratio of the Aid flow (current US$) in European Union in 1970 to that in 1973?
Your answer should be compact. 0.06. What is the ratio of the Aid flow (current US$) of United Kingdom in 1970 to that in 1973?
Ensure brevity in your answer.  0.59. What is the ratio of the Aid flow (current US$) in United States in 1970 to that in 1973?
Ensure brevity in your answer.  0.47. What is the ratio of the Aid flow (current US$) in Iceland in 1970 to that in 1973?
Make the answer very short. 1.09. What is the ratio of the Aid flow (current US$) in European Union in 1970 to that in 1974?
Your answer should be very brief. 0.12. What is the ratio of the Aid flow (current US$) of United Kingdom in 1970 to that in 1974?
Offer a very short reply. 2.2. What is the ratio of the Aid flow (current US$) in United States in 1970 to that in 1974?
Your answer should be compact. 0.41. What is the ratio of the Aid flow (current US$) of Iceland in 1970 to that in 1974?
Your answer should be compact. 2.04. What is the ratio of the Aid flow (current US$) in European Union in 1970 to that in 1975?
Provide a short and direct response. 0.35. What is the ratio of the Aid flow (current US$) in United Kingdom in 1970 to that in 1975?
Ensure brevity in your answer.  1.05. What is the ratio of the Aid flow (current US$) in United States in 1970 to that in 1975?
Offer a terse response. 0.45. What is the ratio of the Aid flow (current US$) of Iceland in 1970 to that in 1975?
Provide a succinct answer. 2.29. What is the ratio of the Aid flow (current US$) in European Union in 1970 to that in 1976?
Offer a very short reply. 0.1. What is the ratio of the Aid flow (current US$) of United States in 1970 to that in 1976?
Give a very brief answer. 0.5. What is the ratio of the Aid flow (current US$) of Iceland in 1970 to that in 1976?
Make the answer very short. 2.22. What is the ratio of the Aid flow (current US$) of European Union in 1971 to that in 1972?
Offer a terse response. 0.21. What is the ratio of the Aid flow (current US$) of United Kingdom in 1971 to that in 1972?
Give a very brief answer. 4.08. What is the ratio of the Aid flow (current US$) in United States in 1971 to that in 1972?
Your response must be concise. 2.31. What is the ratio of the Aid flow (current US$) of Iceland in 1971 to that in 1972?
Offer a terse response. 0.96. What is the ratio of the Aid flow (current US$) in European Union in 1971 to that in 1973?
Your response must be concise. 0.11. What is the ratio of the Aid flow (current US$) of United Kingdom in 1971 to that in 1973?
Make the answer very short. 2.01. What is the ratio of the Aid flow (current US$) in Iceland in 1971 to that in 1973?
Keep it short and to the point. 1.65. What is the ratio of the Aid flow (current US$) of European Union in 1971 to that in 1974?
Your answer should be compact. 0.22. What is the ratio of the Aid flow (current US$) of United Kingdom in 1971 to that in 1974?
Offer a terse response. 7.55. What is the ratio of the Aid flow (current US$) in United States in 1971 to that in 1974?
Make the answer very short. 0.81. What is the ratio of the Aid flow (current US$) in Iceland in 1971 to that in 1974?
Ensure brevity in your answer.  3.09. What is the ratio of the Aid flow (current US$) in European Union in 1971 to that in 1975?
Provide a short and direct response. 0.61. What is the ratio of the Aid flow (current US$) in United Kingdom in 1971 to that in 1975?
Your answer should be compact. 3.6. What is the ratio of the Aid flow (current US$) in United States in 1971 to that in 1975?
Ensure brevity in your answer.  0.9. What is the ratio of the Aid flow (current US$) in Iceland in 1971 to that in 1975?
Provide a short and direct response. 3.48. What is the ratio of the Aid flow (current US$) of United States in 1971 to that in 1976?
Your response must be concise. 1. What is the ratio of the Aid flow (current US$) in Iceland in 1971 to that in 1976?
Keep it short and to the point. 3.37. What is the ratio of the Aid flow (current US$) in European Union in 1972 to that in 1973?
Give a very brief answer. 0.54. What is the ratio of the Aid flow (current US$) of United Kingdom in 1972 to that in 1973?
Offer a very short reply. 0.49. What is the ratio of the Aid flow (current US$) of United States in 1972 to that in 1973?
Your answer should be very brief. 0.41. What is the ratio of the Aid flow (current US$) in Iceland in 1972 to that in 1973?
Your answer should be very brief. 1.71. What is the ratio of the Aid flow (current US$) of European Union in 1972 to that in 1974?
Your answer should be very brief. 1.04. What is the ratio of the Aid flow (current US$) in United Kingdom in 1972 to that in 1974?
Keep it short and to the point. 1.85. What is the ratio of the Aid flow (current US$) of United States in 1972 to that in 1974?
Give a very brief answer. 0.35. What is the ratio of the Aid flow (current US$) of Iceland in 1972 to that in 1974?
Give a very brief answer. 3.21. What is the ratio of the Aid flow (current US$) in European Union in 1972 to that in 1975?
Offer a terse response. 2.91. What is the ratio of the Aid flow (current US$) in United Kingdom in 1972 to that in 1975?
Your answer should be very brief. 0.88. What is the ratio of the Aid flow (current US$) in United States in 1972 to that in 1975?
Make the answer very short. 0.39. What is the ratio of the Aid flow (current US$) of Iceland in 1972 to that in 1975?
Provide a succinct answer. 3.61. What is the ratio of the Aid flow (current US$) in European Union in 1972 to that in 1976?
Offer a terse response. 0.8. What is the ratio of the Aid flow (current US$) of United States in 1972 to that in 1976?
Provide a short and direct response. 0.43. What is the ratio of the Aid flow (current US$) of Iceland in 1972 to that in 1976?
Ensure brevity in your answer.  3.5. What is the ratio of the Aid flow (current US$) of European Union in 1973 to that in 1974?
Offer a terse response. 1.91. What is the ratio of the Aid flow (current US$) in United Kingdom in 1973 to that in 1974?
Provide a succinct answer. 3.75. What is the ratio of the Aid flow (current US$) in United States in 1973 to that in 1974?
Give a very brief answer. 0.86. What is the ratio of the Aid flow (current US$) in Iceland in 1973 to that in 1974?
Give a very brief answer. 1.87. What is the ratio of the Aid flow (current US$) in European Union in 1973 to that in 1975?
Provide a succinct answer. 5.37. What is the ratio of the Aid flow (current US$) of United Kingdom in 1973 to that in 1975?
Your answer should be compact. 1.79. What is the ratio of the Aid flow (current US$) of United States in 1973 to that in 1975?
Provide a succinct answer. 0.96. What is the ratio of the Aid flow (current US$) of Iceland in 1973 to that in 1975?
Provide a succinct answer. 2.11. What is the ratio of the Aid flow (current US$) in European Union in 1973 to that in 1976?
Your answer should be very brief. 1.47. What is the ratio of the Aid flow (current US$) of United States in 1973 to that in 1976?
Ensure brevity in your answer.  1.07. What is the ratio of the Aid flow (current US$) of Iceland in 1973 to that in 1976?
Offer a terse response. 2.05. What is the ratio of the Aid flow (current US$) in European Union in 1974 to that in 1975?
Keep it short and to the point. 2.8. What is the ratio of the Aid flow (current US$) in United Kingdom in 1974 to that in 1975?
Give a very brief answer. 0.48. What is the ratio of the Aid flow (current US$) of United States in 1974 to that in 1975?
Your answer should be very brief. 1.11. What is the ratio of the Aid flow (current US$) of Iceland in 1974 to that in 1975?
Give a very brief answer. 1.13. What is the ratio of the Aid flow (current US$) in European Union in 1974 to that in 1976?
Your answer should be very brief. 0.77. What is the ratio of the Aid flow (current US$) of United States in 1974 to that in 1976?
Offer a terse response. 1.23. What is the ratio of the Aid flow (current US$) of Iceland in 1974 to that in 1976?
Give a very brief answer. 1.09. What is the ratio of the Aid flow (current US$) in European Union in 1975 to that in 1976?
Give a very brief answer. 0.27. What is the ratio of the Aid flow (current US$) of United States in 1975 to that in 1976?
Ensure brevity in your answer.  1.12. What is the ratio of the Aid flow (current US$) of Iceland in 1975 to that in 1976?
Provide a short and direct response. 0.97. What is the difference between the highest and the second highest Aid flow (current US$) of European Union?
Keep it short and to the point. 7.90e+05. What is the difference between the highest and the second highest Aid flow (current US$) in United Kingdom?
Your response must be concise. 7.60e+05. What is the difference between the highest and the second highest Aid flow (current US$) of United States?
Your answer should be compact. 3.53e+06. What is the difference between the highest and the lowest Aid flow (current US$) in European Union?
Provide a short and direct response. 2.31e+06. What is the difference between the highest and the lowest Aid flow (current US$) of United Kingdom?
Keep it short and to the point. 1.51e+06. What is the difference between the highest and the lowest Aid flow (current US$) of United States?
Make the answer very short. 2.40e+07. What is the difference between the highest and the lowest Aid flow (current US$) of Iceland?
Offer a very short reply. 3.32e+06. 